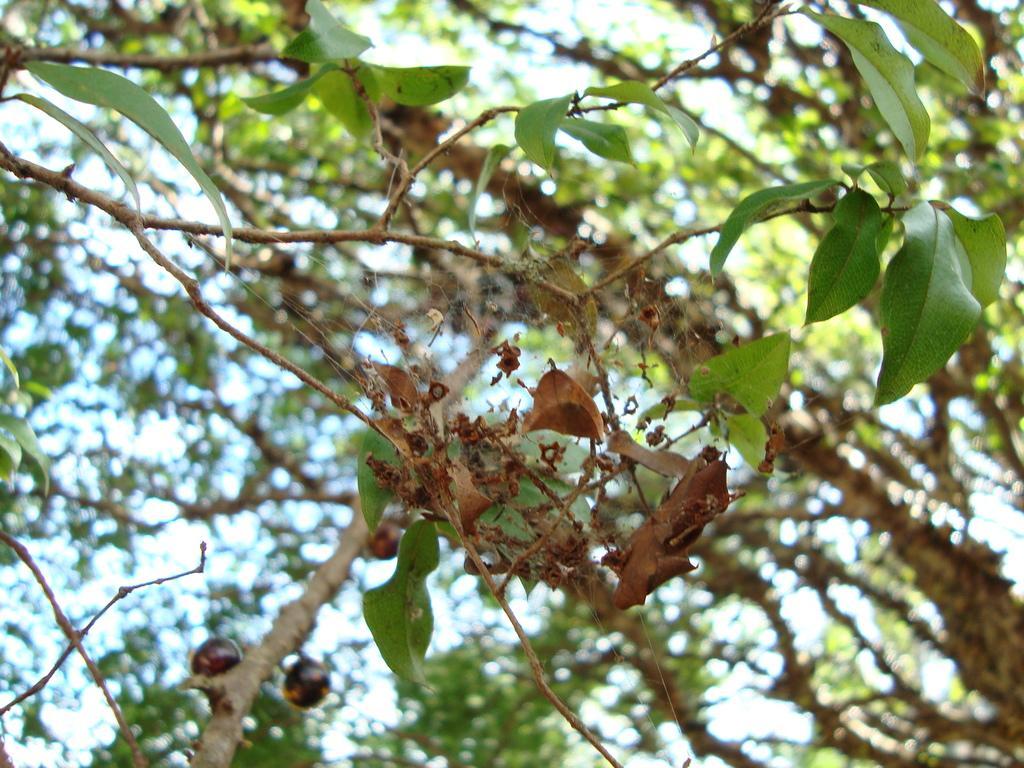Please provide a concise description of this image. In this image there is a tree,a dry leaf. 